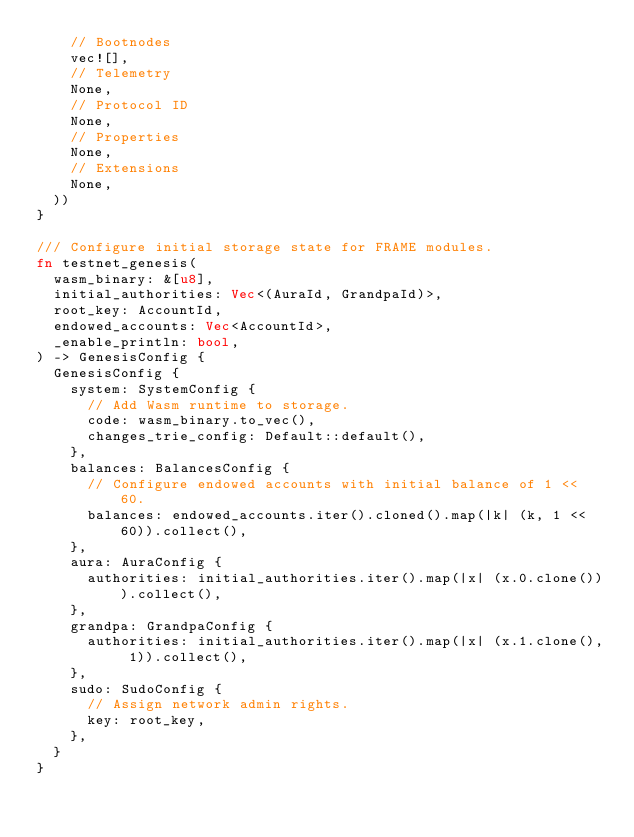<code> <loc_0><loc_0><loc_500><loc_500><_Rust_>		// Bootnodes
		vec![],
		// Telemetry
		None,
		// Protocol ID
		None,
		// Properties
		None,
		// Extensions
		None,
	))
}

/// Configure initial storage state for FRAME modules.
fn testnet_genesis(
	wasm_binary: &[u8],
	initial_authorities: Vec<(AuraId, GrandpaId)>,
	root_key: AccountId,
	endowed_accounts: Vec<AccountId>,
	_enable_println: bool,
) -> GenesisConfig {
	GenesisConfig {
		system: SystemConfig {
			// Add Wasm runtime to storage.
			code: wasm_binary.to_vec(),
			changes_trie_config: Default::default(),
		},
		balances: BalancesConfig {
			// Configure endowed accounts with initial balance of 1 << 60.
			balances: endowed_accounts.iter().cloned().map(|k| (k, 1 << 60)).collect(),
		},
		aura: AuraConfig {
			authorities: initial_authorities.iter().map(|x| (x.0.clone())).collect(),
		},
		grandpa: GrandpaConfig {
			authorities: initial_authorities.iter().map(|x| (x.1.clone(), 1)).collect(),
		},
		sudo: SudoConfig {
			// Assign network admin rights.
			key: root_key,
		},
	}
}
</code> 